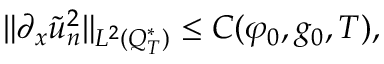Convert formula to latex. <formula><loc_0><loc_0><loc_500><loc_500>\| \partial _ { x } \tilde { u } _ { n } ^ { 2 } \| _ { L ^ { 2 } ( Q _ { T } ^ { * } ) } \leq C ( \varphi _ { 0 } , g _ { 0 } , T ) ,</formula> 